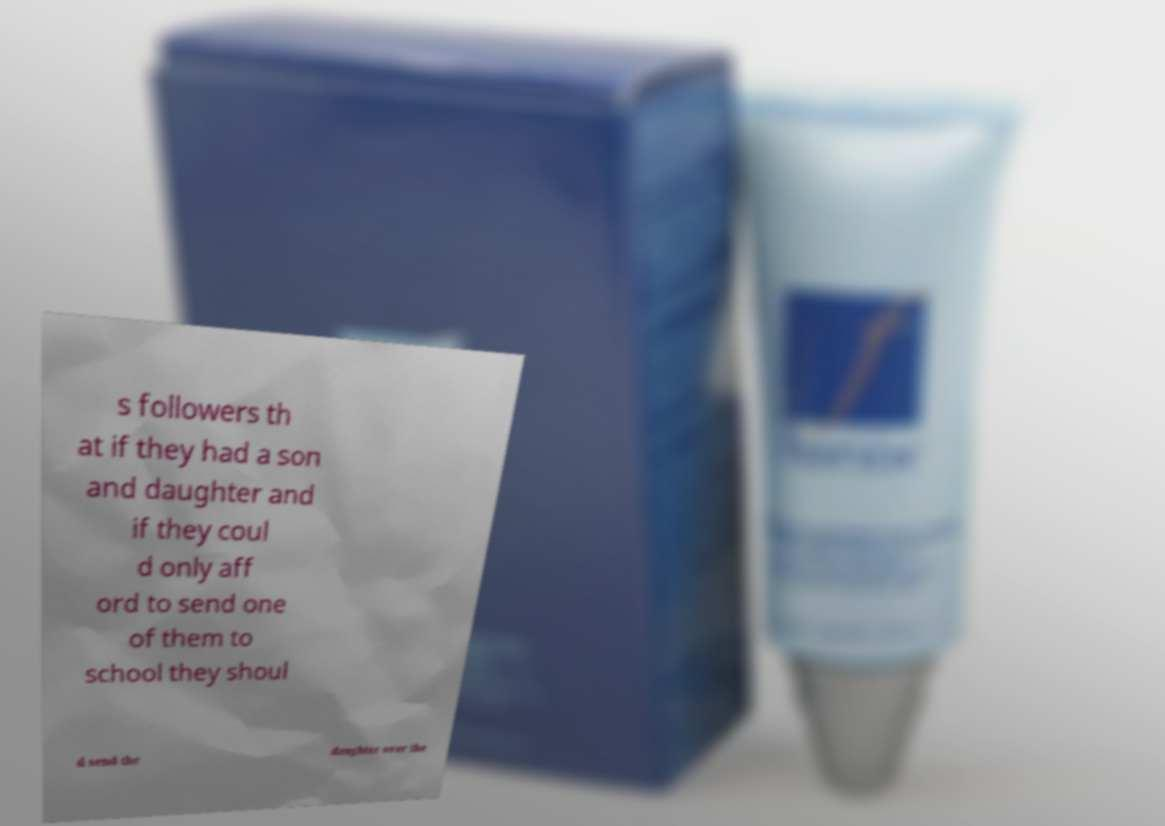Please read and relay the text visible in this image. What does it say? s followers th at if they had a son and daughter and if they coul d only aff ord to send one of them to school they shoul d send the daughter over the 